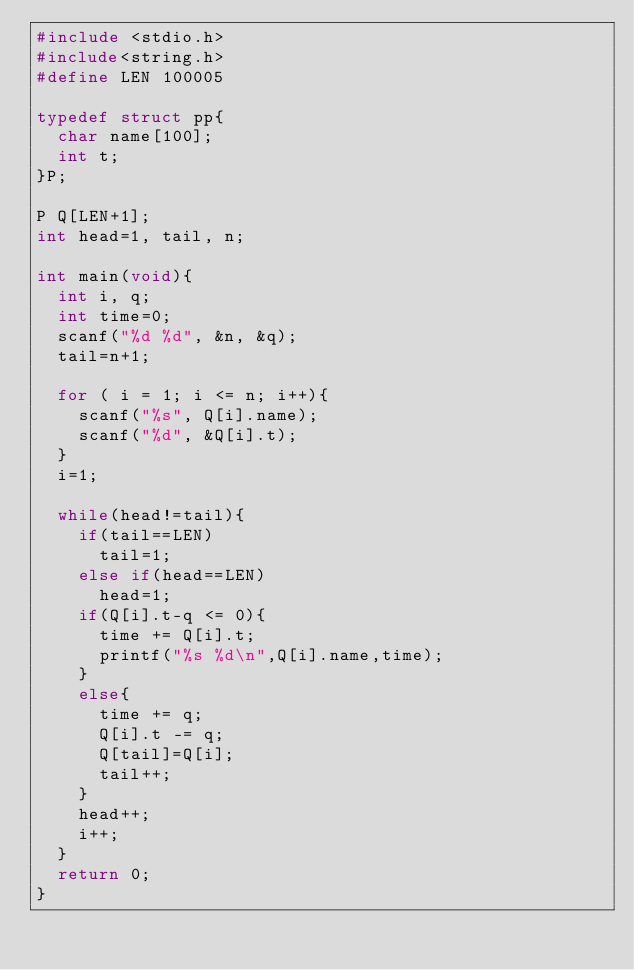<code> <loc_0><loc_0><loc_500><loc_500><_C_>#include <stdio.h>
#include<string.h>
#define LEN 100005

typedef struct pp{
  char name[100];
  int t;
}P;

P Q[LEN+1];
int head=1, tail, n;

int main(void){
  int i, q;
  int time=0;
  scanf("%d %d", &n, &q);
  tail=n+1;

  for ( i = 1; i <= n; i++){
    scanf("%s", Q[i].name);
    scanf("%d", &Q[i].t);
  }
  i=1;

  while(head!=tail){
    if(tail==LEN)
      tail=1;
    else if(head==LEN)
      head=1;
    if(Q[i].t-q <= 0){
      time += Q[i].t;
      printf("%s %d\n",Q[i].name,time);
    }
    else{
      time += q;
      Q[i].t -= q;
      Q[tail]=Q[i];
      tail++;
    }
    head++;
    i++;
  }
  return 0;
}</code> 